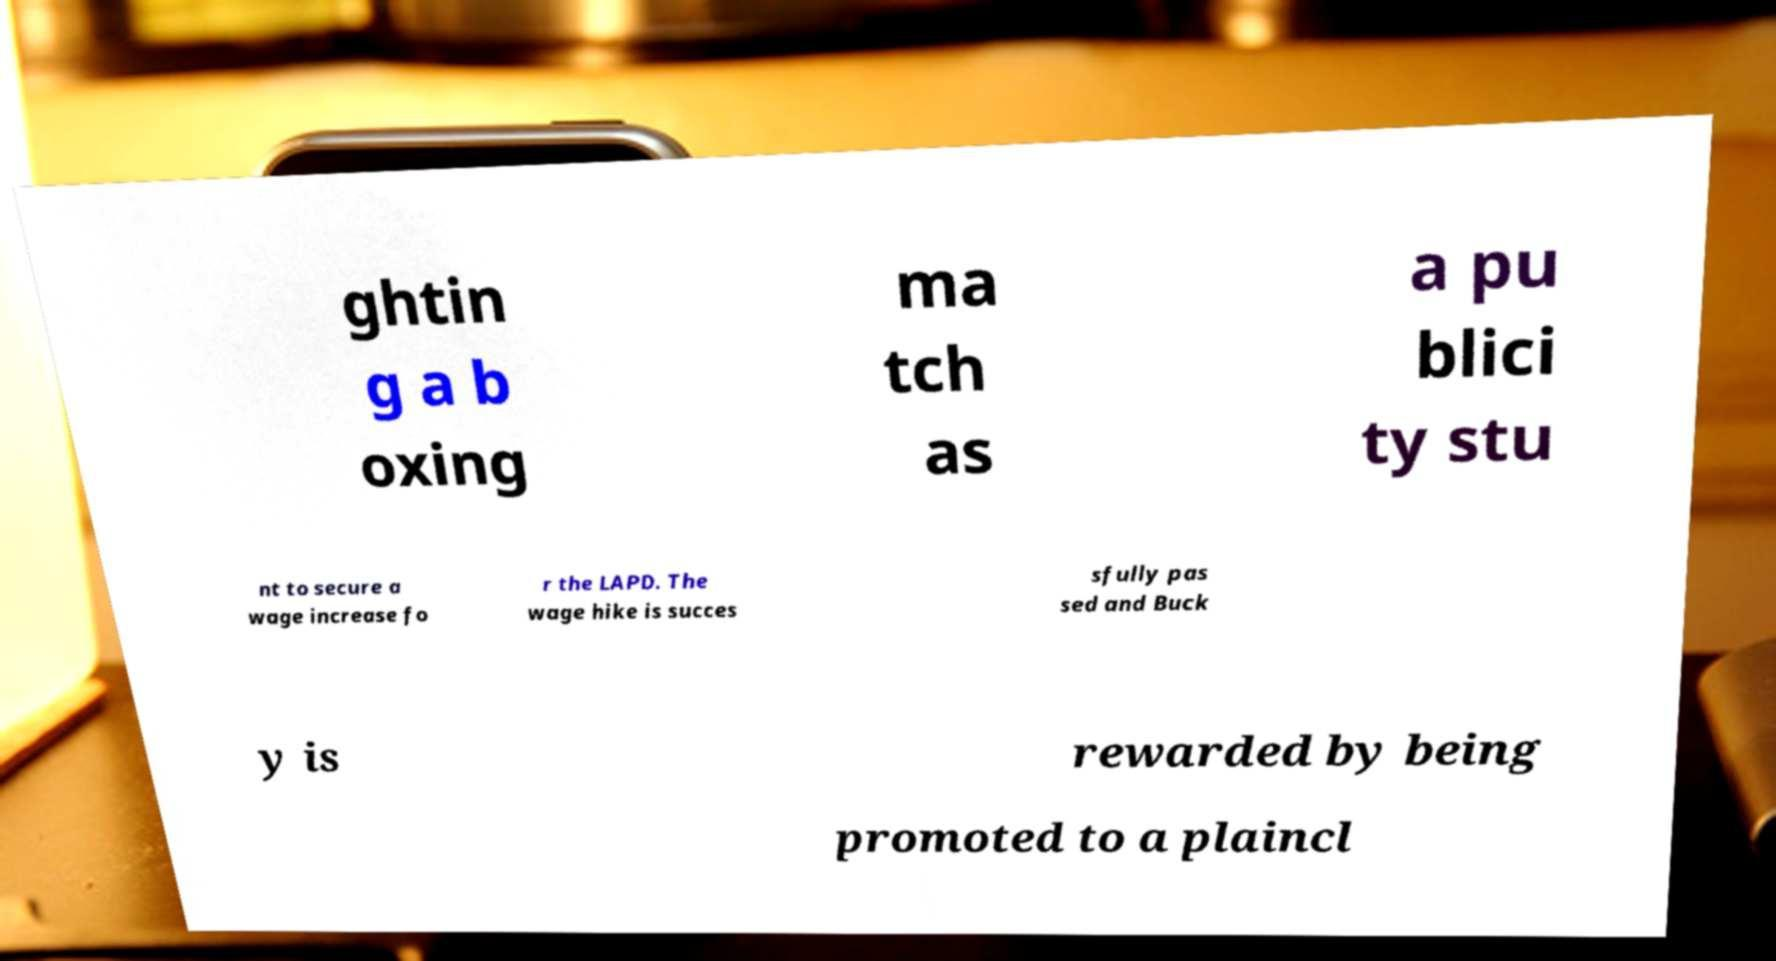For documentation purposes, I need the text within this image transcribed. Could you provide that? ghtin g a b oxing ma tch as a pu blici ty stu nt to secure a wage increase fo r the LAPD. The wage hike is succes sfully pas sed and Buck y is rewarded by being promoted to a plaincl 